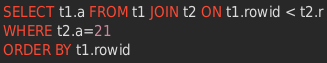<code> <loc_0><loc_0><loc_500><loc_500><_SQL_>SELECT t1.a FROM t1 JOIN t2 ON t1.rowid < t2.r
WHERE t2.a=21
ORDER BY t1.rowid</code> 